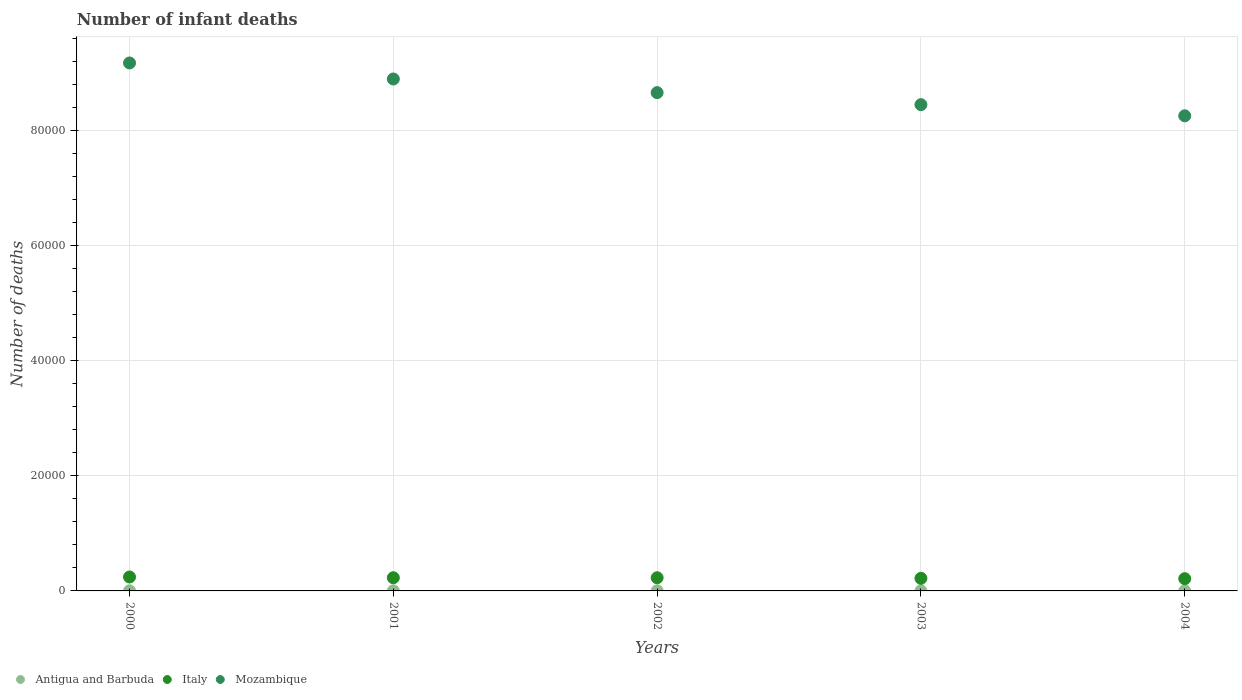Is the number of dotlines equal to the number of legend labels?
Make the answer very short. Yes. What is the number of infant deaths in Italy in 2000?
Provide a short and direct response. 2419. Across all years, what is the maximum number of infant deaths in Italy?
Provide a succinct answer. 2419. Across all years, what is the minimum number of infant deaths in Mozambique?
Offer a terse response. 8.25e+04. In which year was the number of infant deaths in Antigua and Barbuda maximum?
Provide a succinct answer. 2000. In which year was the number of infant deaths in Antigua and Barbuda minimum?
Your answer should be very brief. 2004. What is the total number of infant deaths in Antigua and Barbuda in the graph?
Keep it short and to the point. 99. What is the difference between the number of infant deaths in Italy in 2000 and that in 2003?
Your answer should be compact. 233. What is the difference between the number of infant deaths in Mozambique in 2001 and the number of infant deaths in Antigua and Barbuda in 2000?
Your answer should be very brief. 8.89e+04. What is the average number of infant deaths in Mozambique per year?
Your answer should be very brief. 8.68e+04. In the year 2000, what is the difference between the number of infant deaths in Mozambique and number of infant deaths in Italy?
Keep it short and to the point. 8.93e+04. In how many years, is the number of infant deaths in Italy greater than 20000?
Make the answer very short. 0. What is the ratio of the number of infant deaths in Italy in 2001 to that in 2003?
Offer a terse response. 1.05. Is the difference between the number of infant deaths in Mozambique in 2000 and 2001 greater than the difference between the number of infant deaths in Italy in 2000 and 2001?
Keep it short and to the point. Yes. What is the difference between the highest and the second highest number of infant deaths in Antigua and Barbuda?
Provide a short and direct response. 1. In how many years, is the number of infant deaths in Antigua and Barbuda greater than the average number of infant deaths in Antigua and Barbuda taken over all years?
Give a very brief answer. 3. Is it the case that in every year, the sum of the number of infant deaths in Antigua and Barbuda and number of infant deaths in Mozambique  is greater than the number of infant deaths in Italy?
Provide a succinct answer. Yes. Is the number of infant deaths in Mozambique strictly greater than the number of infant deaths in Antigua and Barbuda over the years?
Offer a terse response. Yes. How many dotlines are there?
Keep it short and to the point. 3. How many years are there in the graph?
Give a very brief answer. 5. Does the graph contain grids?
Your response must be concise. Yes. How are the legend labels stacked?
Your answer should be very brief. Horizontal. What is the title of the graph?
Make the answer very short. Number of infant deaths. Does "Belize" appear as one of the legend labels in the graph?
Offer a terse response. No. What is the label or title of the Y-axis?
Provide a short and direct response. Number of deaths. What is the Number of deaths of Italy in 2000?
Ensure brevity in your answer.  2419. What is the Number of deaths in Mozambique in 2000?
Offer a terse response. 9.17e+04. What is the Number of deaths of Antigua and Barbuda in 2001?
Provide a short and direct response. 21. What is the Number of deaths in Italy in 2001?
Provide a succinct answer. 2292. What is the Number of deaths of Mozambique in 2001?
Offer a very short reply. 8.89e+04. What is the Number of deaths of Italy in 2002?
Provide a succinct answer. 2290. What is the Number of deaths of Mozambique in 2002?
Your answer should be very brief. 8.65e+04. What is the Number of deaths of Antigua and Barbuda in 2003?
Keep it short and to the point. 19. What is the Number of deaths of Italy in 2003?
Provide a succinct answer. 2186. What is the Number of deaths of Mozambique in 2003?
Provide a succinct answer. 8.44e+04. What is the Number of deaths of Italy in 2004?
Your answer should be very brief. 2126. What is the Number of deaths of Mozambique in 2004?
Give a very brief answer. 8.25e+04. Across all years, what is the maximum Number of deaths of Italy?
Give a very brief answer. 2419. Across all years, what is the maximum Number of deaths in Mozambique?
Your response must be concise. 9.17e+04. Across all years, what is the minimum Number of deaths in Italy?
Ensure brevity in your answer.  2126. Across all years, what is the minimum Number of deaths of Mozambique?
Ensure brevity in your answer.  8.25e+04. What is the total Number of deaths of Italy in the graph?
Your answer should be compact. 1.13e+04. What is the total Number of deaths in Mozambique in the graph?
Offer a terse response. 4.34e+05. What is the difference between the Number of deaths in Antigua and Barbuda in 2000 and that in 2001?
Give a very brief answer. 1. What is the difference between the Number of deaths of Italy in 2000 and that in 2001?
Give a very brief answer. 127. What is the difference between the Number of deaths in Mozambique in 2000 and that in 2001?
Offer a very short reply. 2783. What is the difference between the Number of deaths in Antigua and Barbuda in 2000 and that in 2002?
Keep it short and to the point. 2. What is the difference between the Number of deaths of Italy in 2000 and that in 2002?
Give a very brief answer. 129. What is the difference between the Number of deaths of Mozambique in 2000 and that in 2002?
Your answer should be compact. 5152. What is the difference between the Number of deaths of Antigua and Barbuda in 2000 and that in 2003?
Your response must be concise. 3. What is the difference between the Number of deaths in Italy in 2000 and that in 2003?
Provide a short and direct response. 233. What is the difference between the Number of deaths of Mozambique in 2000 and that in 2003?
Provide a succinct answer. 7238. What is the difference between the Number of deaths of Italy in 2000 and that in 2004?
Give a very brief answer. 293. What is the difference between the Number of deaths of Mozambique in 2000 and that in 2004?
Keep it short and to the point. 9178. What is the difference between the Number of deaths in Antigua and Barbuda in 2001 and that in 2002?
Keep it short and to the point. 1. What is the difference between the Number of deaths of Mozambique in 2001 and that in 2002?
Keep it short and to the point. 2369. What is the difference between the Number of deaths of Italy in 2001 and that in 2003?
Make the answer very short. 106. What is the difference between the Number of deaths in Mozambique in 2001 and that in 2003?
Make the answer very short. 4455. What is the difference between the Number of deaths of Italy in 2001 and that in 2004?
Ensure brevity in your answer.  166. What is the difference between the Number of deaths in Mozambique in 2001 and that in 2004?
Make the answer very short. 6395. What is the difference between the Number of deaths in Italy in 2002 and that in 2003?
Make the answer very short. 104. What is the difference between the Number of deaths of Mozambique in 2002 and that in 2003?
Your answer should be very brief. 2086. What is the difference between the Number of deaths in Antigua and Barbuda in 2002 and that in 2004?
Make the answer very short. 3. What is the difference between the Number of deaths in Italy in 2002 and that in 2004?
Your answer should be very brief. 164. What is the difference between the Number of deaths of Mozambique in 2002 and that in 2004?
Provide a succinct answer. 4026. What is the difference between the Number of deaths in Mozambique in 2003 and that in 2004?
Make the answer very short. 1940. What is the difference between the Number of deaths in Antigua and Barbuda in 2000 and the Number of deaths in Italy in 2001?
Offer a very short reply. -2270. What is the difference between the Number of deaths in Antigua and Barbuda in 2000 and the Number of deaths in Mozambique in 2001?
Keep it short and to the point. -8.89e+04. What is the difference between the Number of deaths in Italy in 2000 and the Number of deaths in Mozambique in 2001?
Offer a terse response. -8.65e+04. What is the difference between the Number of deaths of Antigua and Barbuda in 2000 and the Number of deaths of Italy in 2002?
Provide a succinct answer. -2268. What is the difference between the Number of deaths in Antigua and Barbuda in 2000 and the Number of deaths in Mozambique in 2002?
Your answer should be very brief. -8.65e+04. What is the difference between the Number of deaths in Italy in 2000 and the Number of deaths in Mozambique in 2002?
Provide a succinct answer. -8.41e+04. What is the difference between the Number of deaths in Antigua and Barbuda in 2000 and the Number of deaths in Italy in 2003?
Make the answer very short. -2164. What is the difference between the Number of deaths of Antigua and Barbuda in 2000 and the Number of deaths of Mozambique in 2003?
Provide a succinct answer. -8.44e+04. What is the difference between the Number of deaths in Italy in 2000 and the Number of deaths in Mozambique in 2003?
Provide a short and direct response. -8.20e+04. What is the difference between the Number of deaths in Antigua and Barbuda in 2000 and the Number of deaths in Italy in 2004?
Offer a very short reply. -2104. What is the difference between the Number of deaths in Antigua and Barbuda in 2000 and the Number of deaths in Mozambique in 2004?
Your answer should be very brief. -8.25e+04. What is the difference between the Number of deaths of Italy in 2000 and the Number of deaths of Mozambique in 2004?
Your response must be concise. -8.01e+04. What is the difference between the Number of deaths in Antigua and Barbuda in 2001 and the Number of deaths in Italy in 2002?
Give a very brief answer. -2269. What is the difference between the Number of deaths of Antigua and Barbuda in 2001 and the Number of deaths of Mozambique in 2002?
Your response must be concise. -8.65e+04. What is the difference between the Number of deaths of Italy in 2001 and the Number of deaths of Mozambique in 2002?
Give a very brief answer. -8.42e+04. What is the difference between the Number of deaths of Antigua and Barbuda in 2001 and the Number of deaths of Italy in 2003?
Offer a very short reply. -2165. What is the difference between the Number of deaths in Antigua and Barbuda in 2001 and the Number of deaths in Mozambique in 2003?
Provide a short and direct response. -8.44e+04. What is the difference between the Number of deaths of Italy in 2001 and the Number of deaths of Mozambique in 2003?
Your response must be concise. -8.22e+04. What is the difference between the Number of deaths in Antigua and Barbuda in 2001 and the Number of deaths in Italy in 2004?
Your answer should be compact. -2105. What is the difference between the Number of deaths in Antigua and Barbuda in 2001 and the Number of deaths in Mozambique in 2004?
Offer a very short reply. -8.25e+04. What is the difference between the Number of deaths of Italy in 2001 and the Number of deaths of Mozambique in 2004?
Your response must be concise. -8.02e+04. What is the difference between the Number of deaths in Antigua and Barbuda in 2002 and the Number of deaths in Italy in 2003?
Offer a terse response. -2166. What is the difference between the Number of deaths of Antigua and Barbuda in 2002 and the Number of deaths of Mozambique in 2003?
Keep it short and to the point. -8.44e+04. What is the difference between the Number of deaths of Italy in 2002 and the Number of deaths of Mozambique in 2003?
Your response must be concise. -8.22e+04. What is the difference between the Number of deaths of Antigua and Barbuda in 2002 and the Number of deaths of Italy in 2004?
Give a very brief answer. -2106. What is the difference between the Number of deaths of Antigua and Barbuda in 2002 and the Number of deaths of Mozambique in 2004?
Your answer should be very brief. -8.25e+04. What is the difference between the Number of deaths in Italy in 2002 and the Number of deaths in Mozambique in 2004?
Provide a short and direct response. -8.02e+04. What is the difference between the Number of deaths of Antigua and Barbuda in 2003 and the Number of deaths of Italy in 2004?
Ensure brevity in your answer.  -2107. What is the difference between the Number of deaths in Antigua and Barbuda in 2003 and the Number of deaths in Mozambique in 2004?
Provide a succinct answer. -8.25e+04. What is the difference between the Number of deaths in Italy in 2003 and the Number of deaths in Mozambique in 2004?
Keep it short and to the point. -8.03e+04. What is the average Number of deaths of Antigua and Barbuda per year?
Make the answer very short. 19.8. What is the average Number of deaths in Italy per year?
Your answer should be compact. 2262.6. What is the average Number of deaths in Mozambique per year?
Offer a very short reply. 8.68e+04. In the year 2000, what is the difference between the Number of deaths in Antigua and Barbuda and Number of deaths in Italy?
Keep it short and to the point. -2397. In the year 2000, what is the difference between the Number of deaths of Antigua and Barbuda and Number of deaths of Mozambique?
Provide a short and direct response. -9.17e+04. In the year 2000, what is the difference between the Number of deaths in Italy and Number of deaths in Mozambique?
Keep it short and to the point. -8.93e+04. In the year 2001, what is the difference between the Number of deaths in Antigua and Barbuda and Number of deaths in Italy?
Give a very brief answer. -2271. In the year 2001, what is the difference between the Number of deaths in Antigua and Barbuda and Number of deaths in Mozambique?
Give a very brief answer. -8.89e+04. In the year 2001, what is the difference between the Number of deaths in Italy and Number of deaths in Mozambique?
Your answer should be compact. -8.66e+04. In the year 2002, what is the difference between the Number of deaths of Antigua and Barbuda and Number of deaths of Italy?
Your answer should be compact. -2270. In the year 2002, what is the difference between the Number of deaths in Antigua and Barbuda and Number of deaths in Mozambique?
Offer a very short reply. -8.65e+04. In the year 2002, what is the difference between the Number of deaths in Italy and Number of deaths in Mozambique?
Ensure brevity in your answer.  -8.42e+04. In the year 2003, what is the difference between the Number of deaths of Antigua and Barbuda and Number of deaths of Italy?
Ensure brevity in your answer.  -2167. In the year 2003, what is the difference between the Number of deaths in Antigua and Barbuda and Number of deaths in Mozambique?
Your response must be concise. -8.44e+04. In the year 2003, what is the difference between the Number of deaths in Italy and Number of deaths in Mozambique?
Your answer should be compact. -8.23e+04. In the year 2004, what is the difference between the Number of deaths of Antigua and Barbuda and Number of deaths of Italy?
Provide a succinct answer. -2109. In the year 2004, what is the difference between the Number of deaths in Antigua and Barbuda and Number of deaths in Mozambique?
Give a very brief answer. -8.25e+04. In the year 2004, what is the difference between the Number of deaths in Italy and Number of deaths in Mozambique?
Offer a very short reply. -8.04e+04. What is the ratio of the Number of deaths in Antigua and Barbuda in 2000 to that in 2001?
Your answer should be compact. 1.05. What is the ratio of the Number of deaths in Italy in 2000 to that in 2001?
Your answer should be compact. 1.06. What is the ratio of the Number of deaths of Mozambique in 2000 to that in 2001?
Offer a terse response. 1.03. What is the ratio of the Number of deaths of Antigua and Barbuda in 2000 to that in 2002?
Provide a succinct answer. 1.1. What is the ratio of the Number of deaths of Italy in 2000 to that in 2002?
Offer a terse response. 1.06. What is the ratio of the Number of deaths in Mozambique in 2000 to that in 2002?
Your answer should be very brief. 1.06. What is the ratio of the Number of deaths in Antigua and Barbuda in 2000 to that in 2003?
Make the answer very short. 1.16. What is the ratio of the Number of deaths of Italy in 2000 to that in 2003?
Give a very brief answer. 1.11. What is the ratio of the Number of deaths in Mozambique in 2000 to that in 2003?
Offer a terse response. 1.09. What is the ratio of the Number of deaths in Antigua and Barbuda in 2000 to that in 2004?
Your response must be concise. 1.29. What is the ratio of the Number of deaths in Italy in 2000 to that in 2004?
Ensure brevity in your answer.  1.14. What is the ratio of the Number of deaths in Mozambique in 2000 to that in 2004?
Your answer should be very brief. 1.11. What is the ratio of the Number of deaths in Mozambique in 2001 to that in 2002?
Provide a succinct answer. 1.03. What is the ratio of the Number of deaths in Antigua and Barbuda in 2001 to that in 2003?
Provide a succinct answer. 1.11. What is the ratio of the Number of deaths of Italy in 2001 to that in 2003?
Offer a very short reply. 1.05. What is the ratio of the Number of deaths in Mozambique in 2001 to that in 2003?
Give a very brief answer. 1.05. What is the ratio of the Number of deaths of Antigua and Barbuda in 2001 to that in 2004?
Make the answer very short. 1.24. What is the ratio of the Number of deaths of Italy in 2001 to that in 2004?
Your answer should be compact. 1.08. What is the ratio of the Number of deaths in Mozambique in 2001 to that in 2004?
Your response must be concise. 1.08. What is the ratio of the Number of deaths of Antigua and Barbuda in 2002 to that in 2003?
Offer a very short reply. 1.05. What is the ratio of the Number of deaths of Italy in 2002 to that in 2003?
Your response must be concise. 1.05. What is the ratio of the Number of deaths of Mozambique in 2002 to that in 2003?
Offer a very short reply. 1.02. What is the ratio of the Number of deaths of Antigua and Barbuda in 2002 to that in 2004?
Make the answer very short. 1.18. What is the ratio of the Number of deaths in Italy in 2002 to that in 2004?
Provide a short and direct response. 1.08. What is the ratio of the Number of deaths in Mozambique in 2002 to that in 2004?
Offer a very short reply. 1.05. What is the ratio of the Number of deaths in Antigua and Barbuda in 2003 to that in 2004?
Make the answer very short. 1.12. What is the ratio of the Number of deaths of Italy in 2003 to that in 2004?
Your answer should be compact. 1.03. What is the ratio of the Number of deaths of Mozambique in 2003 to that in 2004?
Make the answer very short. 1.02. What is the difference between the highest and the second highest Number of deaths of Italy?
Offer a very short reply. 127. What is the difference between the highest and the second highest Number of deaths in Mozambique?
Keep it short and to the point. 2783. What is the difference between the highest and the lowest Number of deaths of Antigua and Barbuda?
Offer a very short reply. 5. What is the difference between the highest and the lowest Number of deaths in Italy?
Your answer should be compact. 293. What is the difference between the highest and the lowest Number of deaths of Mozambique?
Your response must be concise. 9178. 